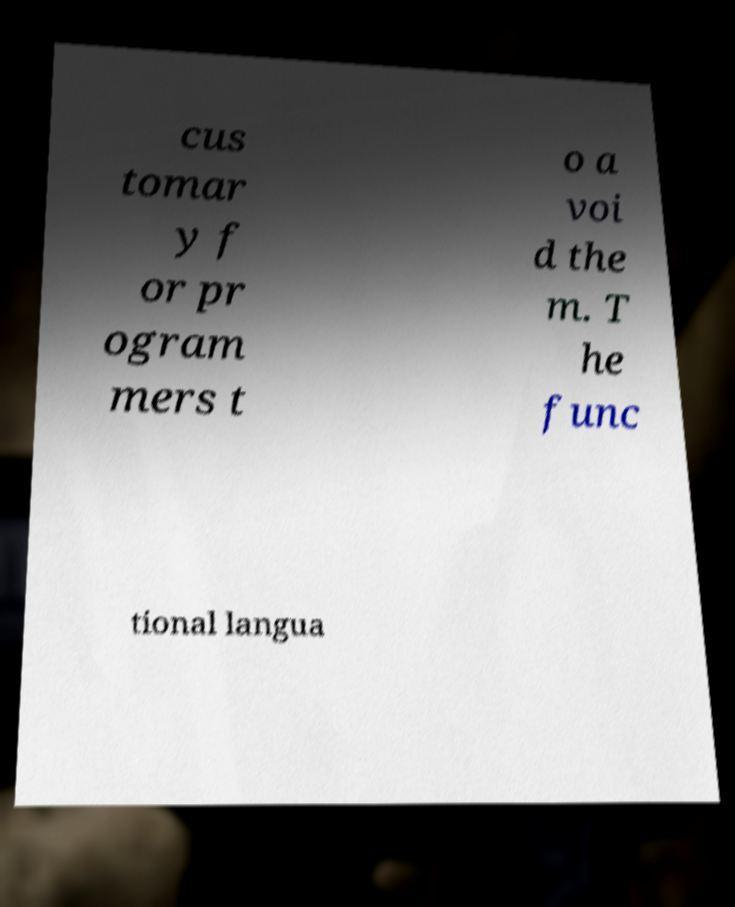Please identify and transcribe the text found in this image. cus tomar y f or pr ogram mers t o a voi d the m. T he func tional langua 